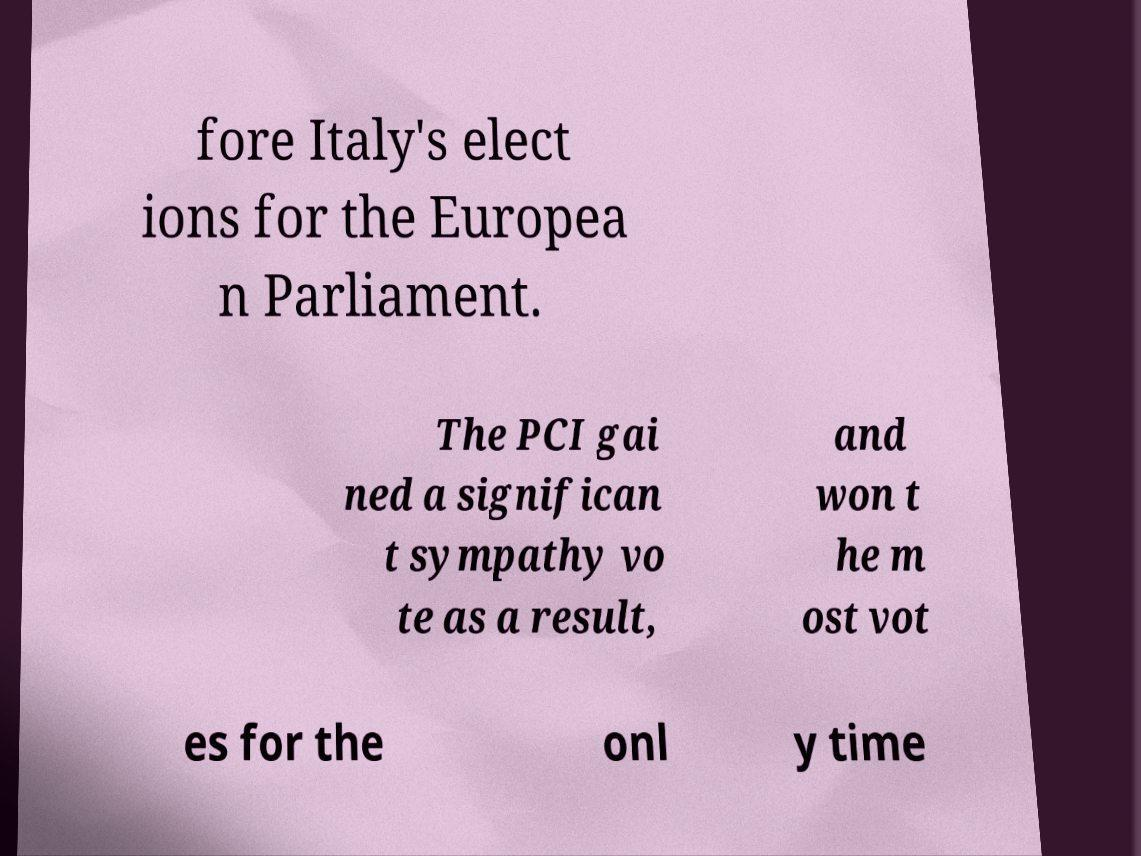Please identify and transcribe the text found in this image. fore Italy's elect ions for the Europea n Parliament. The PCI gai ned a significan t sympathy vo te as a result, and won t he m ost vot es for the onl y time 